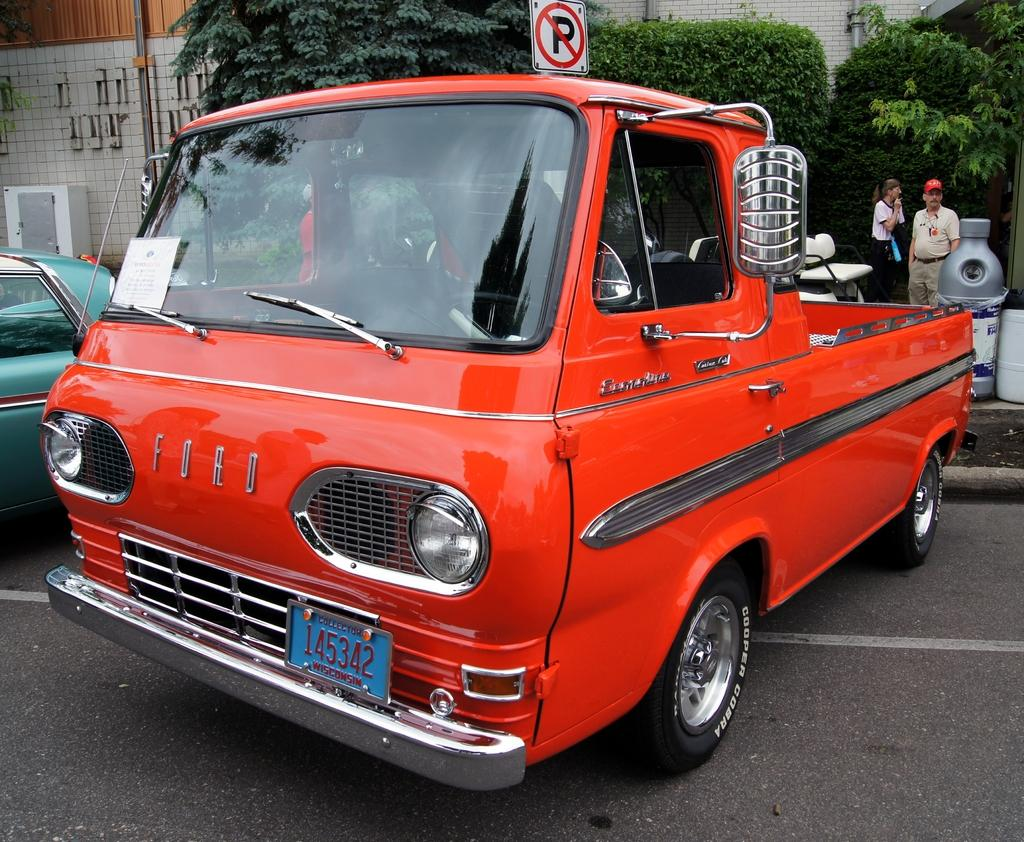Provide a one-sentence caption for the provided image. a very old orange Ford vehicle is sitting in a no parking zone. 